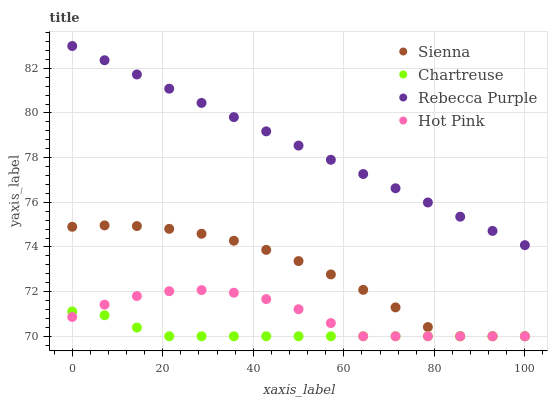Does Chartreuse have the minimum area under the curve?
Answer yes or no. Yes. Does Rebecca Purple have the maximum area under the curve?
Answer yes or no. Yes. Does Hot Pink have the minimum area under the curve?
Answer yes or no. No. Does Hot Pink have the maximum area under the curve?
Answer yes or no. No. Is Rebecca Purple the smoothest?
Answer yes or no. Yes. Is Sienna the roughest?
Answer yes or no. Yes. Is Chartreuse the smoothest?
Answer yes or no. No. Is Chartreuse the roughest?
Answer yes or no. No. Does Sienna have the lowest value?
Answer yes or no. Yes. Does Rebecca Purple have the lowest value?
Answer yes or no. No. Does Rebecca Purple have the highest value?
Answer yes or no. Yes. Does Hot Pink have the highest value?
Answer yes or no. No. Is Sienna less than Rebecca Purple?
Answer yes or no. Yes. Is Rebecca Purple greater than Hot Pink?
Answer yes or no. Yes. Does Hot Pink intersect Sienna?
Answer yes or no. Yes. Is Hot Pink less than Sienna?
Answer yes or no. No. Is Hot Pink greater than Sienna?
Answer yes or no. No. Does Sienna intersect Rebecca Purple?
Answer yes or no. No. 